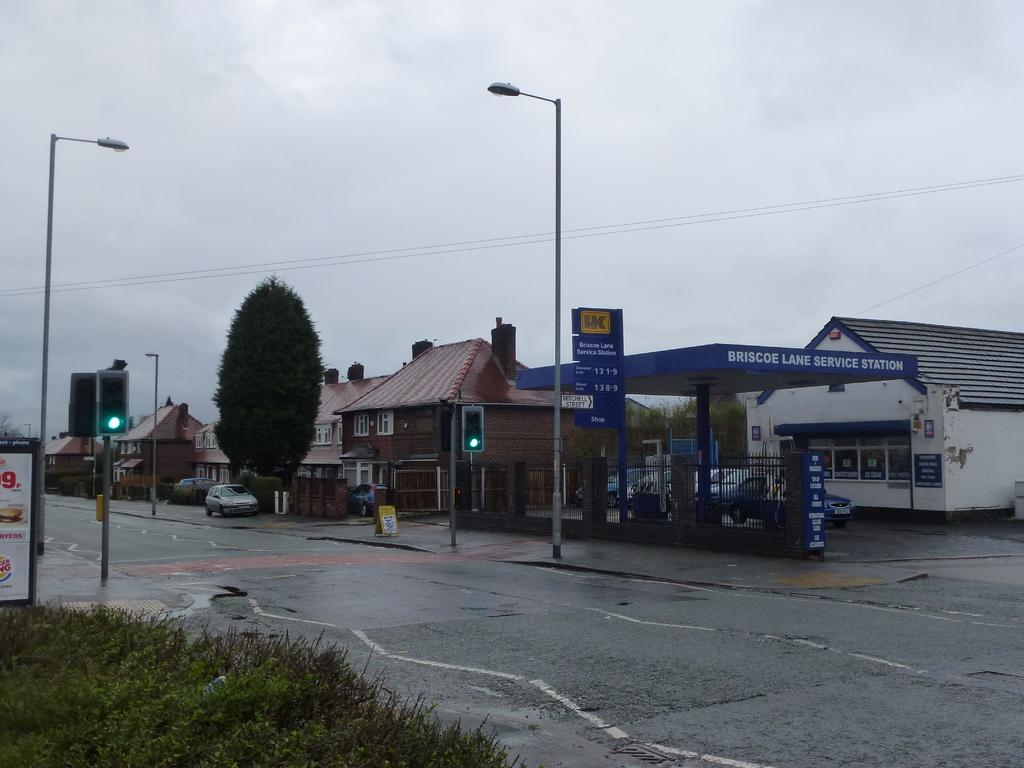What is the main feature of the image? There is a road in the image. What else can be seen alongside the road? There are plants, poles, traffic signals, vehicles, trees, a poster, houses with windows, and some objects in the image. Can you describe the houses in the image? The houses have windows. What is visible in the background of the image? The sky is visible in the background of the image. What type of sofa can be seen in the image? There is no sofa present in the image. What rhythm is being played by the vehicles in the image? The vehicles in the image are not playing any rhythm; they are stationary objects. 